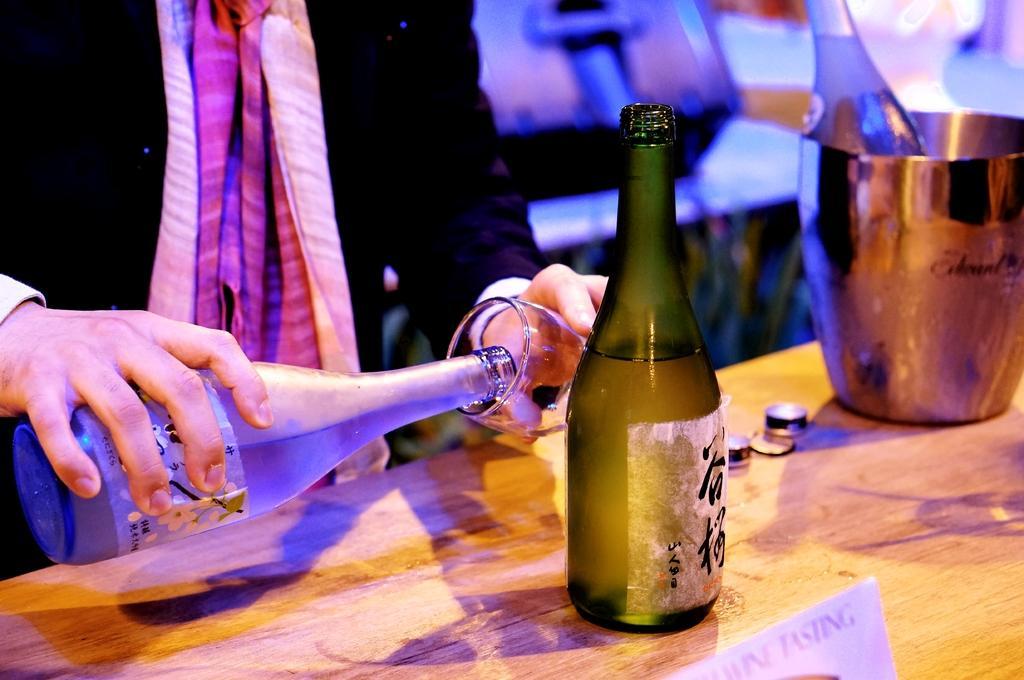Could you give a brief overview of what you see in this image? In this picture, we see a person wearing black blazer is holding glass in one of his hands and on the other, in the other hand he is holding wine bottle. In front of him, we see a table on which green color bottle, glass are placed on it. 